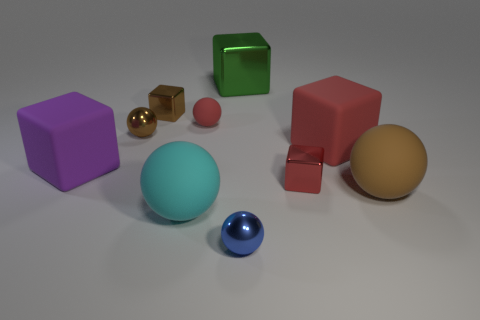What can you infer about the texture of the objects? The objects in the image have a smooth texture with a matte finish. There are no visible signs of roughness or irregularities, suggesting that the surfaces are idealized and clean, possibly indicative of a computer-generated rendering. 